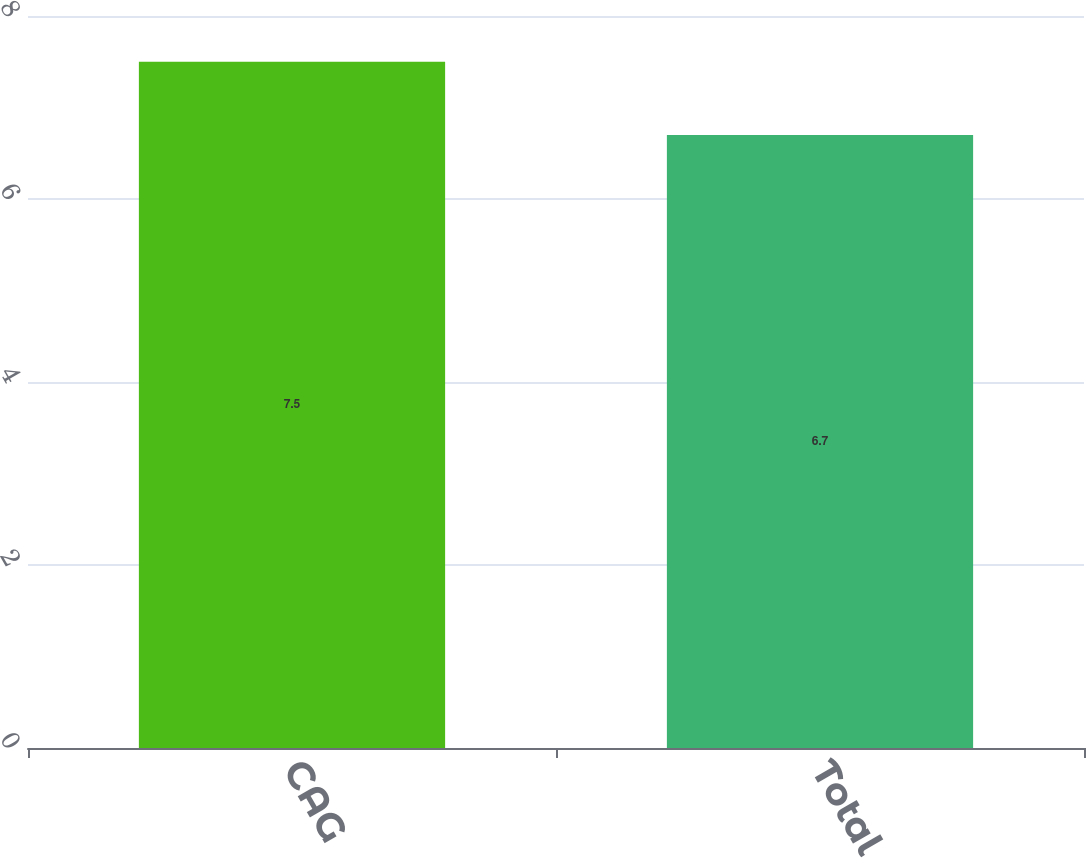<chart> <loc_0><loc_0><loc_500><loc_500><bar_chart><fcel>CAG<fcel>Total<nl><fcel>7.5<fcel>6.7<nl></chart> 